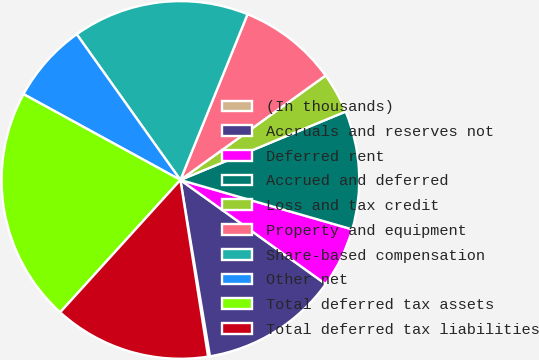Convert chart to OTSL. <chart><loc_0><loc_0><loc_500><loc_500><pie_chart><fcel>(In thousands)<fcel>Accruals and reserves not<fcel>Deferred rent<fcel>Accrued and deferred<fcel>Loss and tax credit<fcel>Property and equipment<fcel>Share-based compensation<fcel>Other net<fcel>Total deferred tax assets<fcel>Total deferred tax liabilities<nl><fcel>0.17%<fcel>12.46%<fcel>5.44%<fcel>10.7%<fcel>3.68%<fcel>8.95%<fcel>15.97%<fcel>7.19%<fcel>21.23%<fcel>14.21%<nl></chart> 